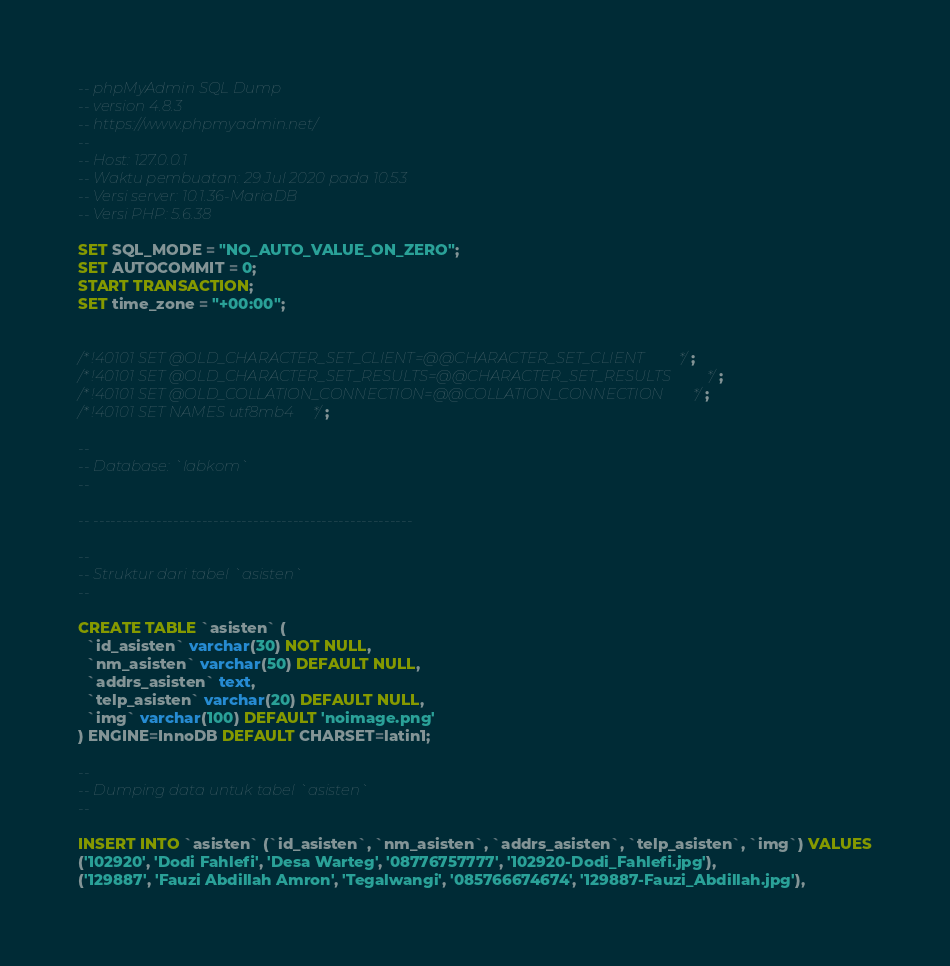<code> <loc_0><loc_0><loc_500><loc_500><_SQL_>-- phpMyAdmin SQL Dump
-- version 4.8.3
-- https://www.phpmyadmin.net/
--
-- Host: 127.0.0.1
-- Waktu pembuatan: 29 Jul 2020 pada 10.53
-- Versi server: 10.1.36-MariaDB
-- Versi PHP: 5.6.38

SET SQL_MODE = "NO_AUTO_VALUE_ON_ZERO";
SET AUTOCOMMIT = 0;
START TRANSACTION;
SET time_zone = "+00:00";


/*!40101 SET @OLD_CHARACTER_SET_CLIENT=@@CHARACTER_SET_CLIENT */;
/*!40101 SET @OLD_CHARACTER_SET_RESULTS=@@CHARACTER_SET_RESULTS */;
/*!40101 SET @OLD_COLLATION_CONNECTION=@@COLLATION_CONNECTION */;
/*!40101 SET NAMES utf8mb4 */;

--
-- Database: `labkom`
--

-- --------------------------------------------------------

--
-- Struktur dari tabel `asisten`
--

CREATE TABLE `asisten` (
  `id_asisten` varchar(30) NOT NULL,
  `nm_asisten` varchar(50) DEFAULT NULL,
  `addrs_asisten` text,
  `telp_asisten` varchar(20) DEFAULT NULL,
  `img` varchar(100) DEFAULT 'noimage.png'
) ENGINE=InnoDB DEFAULT CHARSET=latin1;

--
-- Dumping data untuk tabel `asisten`
--

INSERT INTO `asisten` (`id_asisten`, `nm_asisten`, `addrs_asisten`, `telp_asisten`, `img`) VALUES
('102920', 'Dodi Fahlefi', 'Desa Warteg', '08776757777', '102920-Dodi_Fahlefi.jpg'),
('129887', 'Fauzi Abdillah Amron', 'Tegalwangi', '085766674674', '129887-Fauzi_Abdillah.jpg'),</code> 